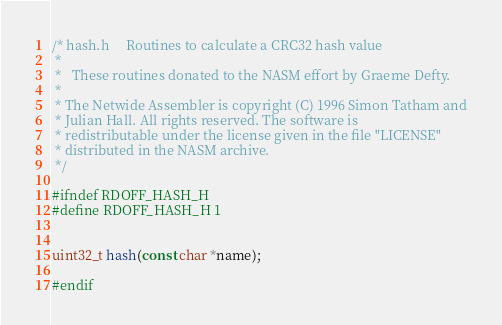Convert code to text. <code><loc_0><loc_0><loc_500><loc_500><_C_>/* hash.h     Routines to calculate a CRC32 hash value
 *
 *   These routines donated to the NASM effort by Graeme Defty.
 *
 * The Netwide Assembler is copyright (C) 1996 Simon Tatham and
 * Julian Hall. All rights reserved. The software is
 * redistributable under the license given in the file "LICENSE"
 * distributed in the NASM archive.
 */

#ifndef RDOFF_HASH_H
#define RDOFF_HASH_H 1


uint32_t hash(const char *name);

#endif
</code> 